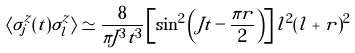<formula> <loc_0><loc_0><loc_500><loc_500>\langle \sigma _ { j } ^ { z } ( t ) \sigma _ { l } ^ { z } \rangle \simeq \frac { 8 } { \pi J ^ { 3 } t ^ { 3 } } \left [ \sin ^ { 2 } \left ( J t - \frac { \pi r } { 2 } \right ) \right ] l ^ { 2 } ( l + r ) ^ { 2 }</formula> 